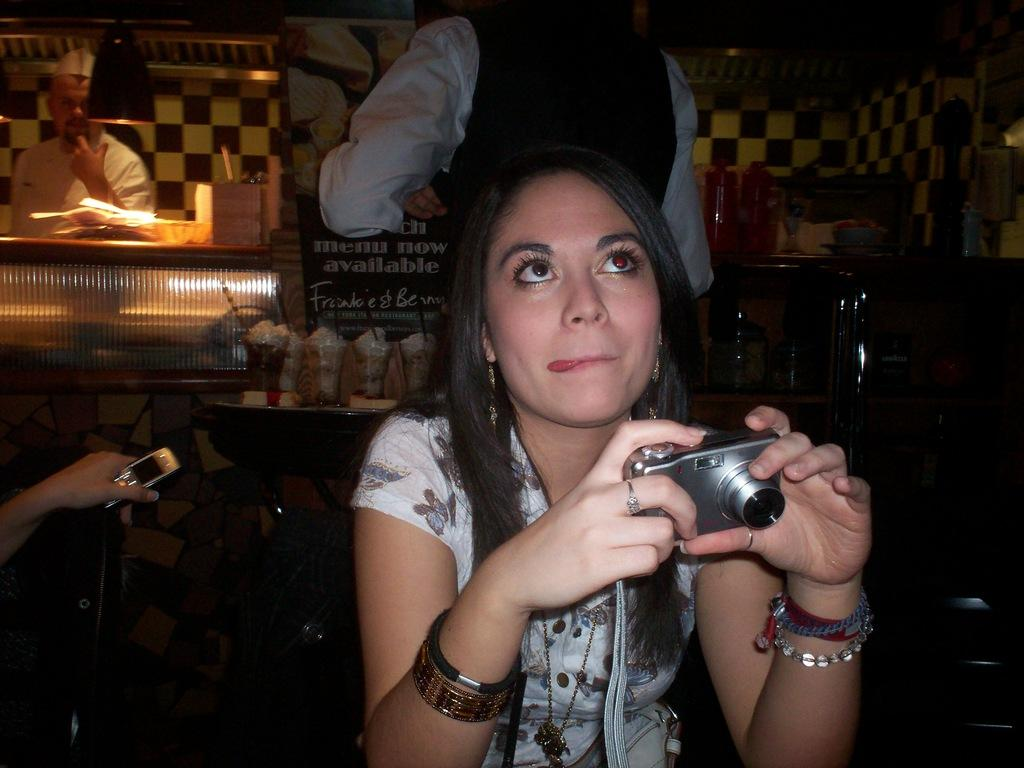What is the woman in the image doing? The woman is sitting and operating a camera in the image. How many people can be seen behind the woman? There are many people behind the woman in the image. What type of knife is the woman using to act in the image? There is no knife or act present in the image; the woman is simply operating a camera. 